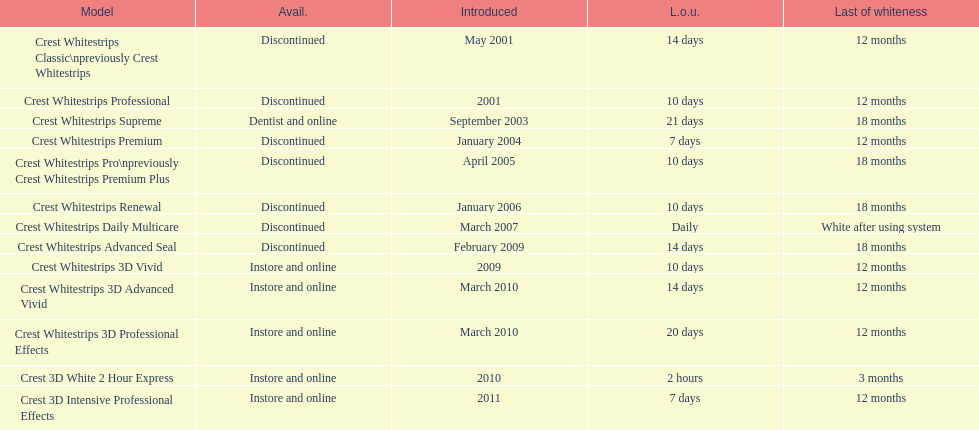What is the product that made its debut in the same month as the crest whitestrips 3d advanced vivid? Crest Whitestrips 3D Professional Effects. 